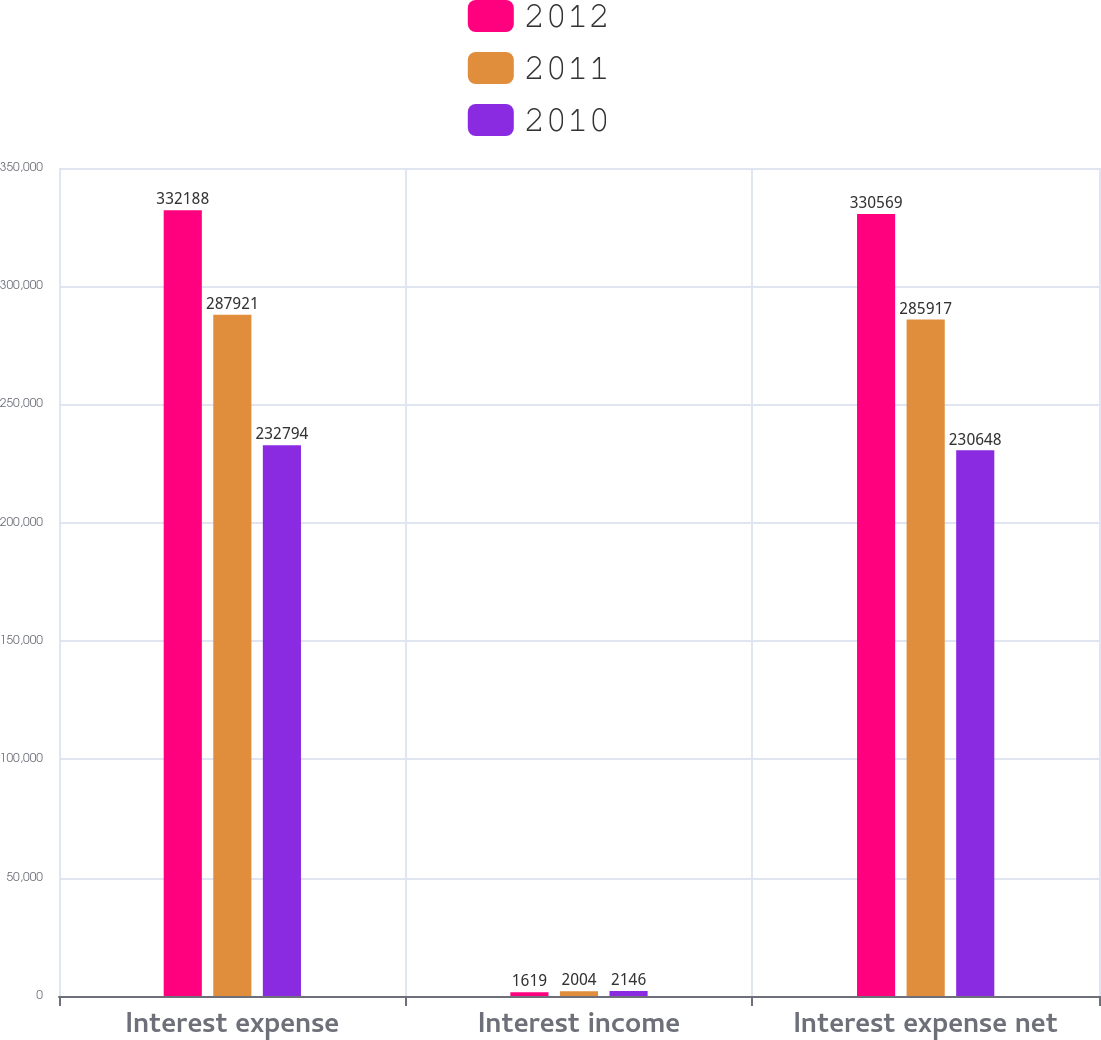<chart> <loc_0><loc_0><loc_500><loc_500><stacked_bar_chart><ecel><fcel>Interest expense<fcel>Interest income<fcel>Interest expense net<nl><fcel>2012<fcel>332188<fcel>1619<fcel>330569<nl><fcel>2011<fcel>287921<fcel>2004<fcel>285917<nl><fcel>2010<fcel>232794<fcel>2146<fcel>230648<nl></chart> 